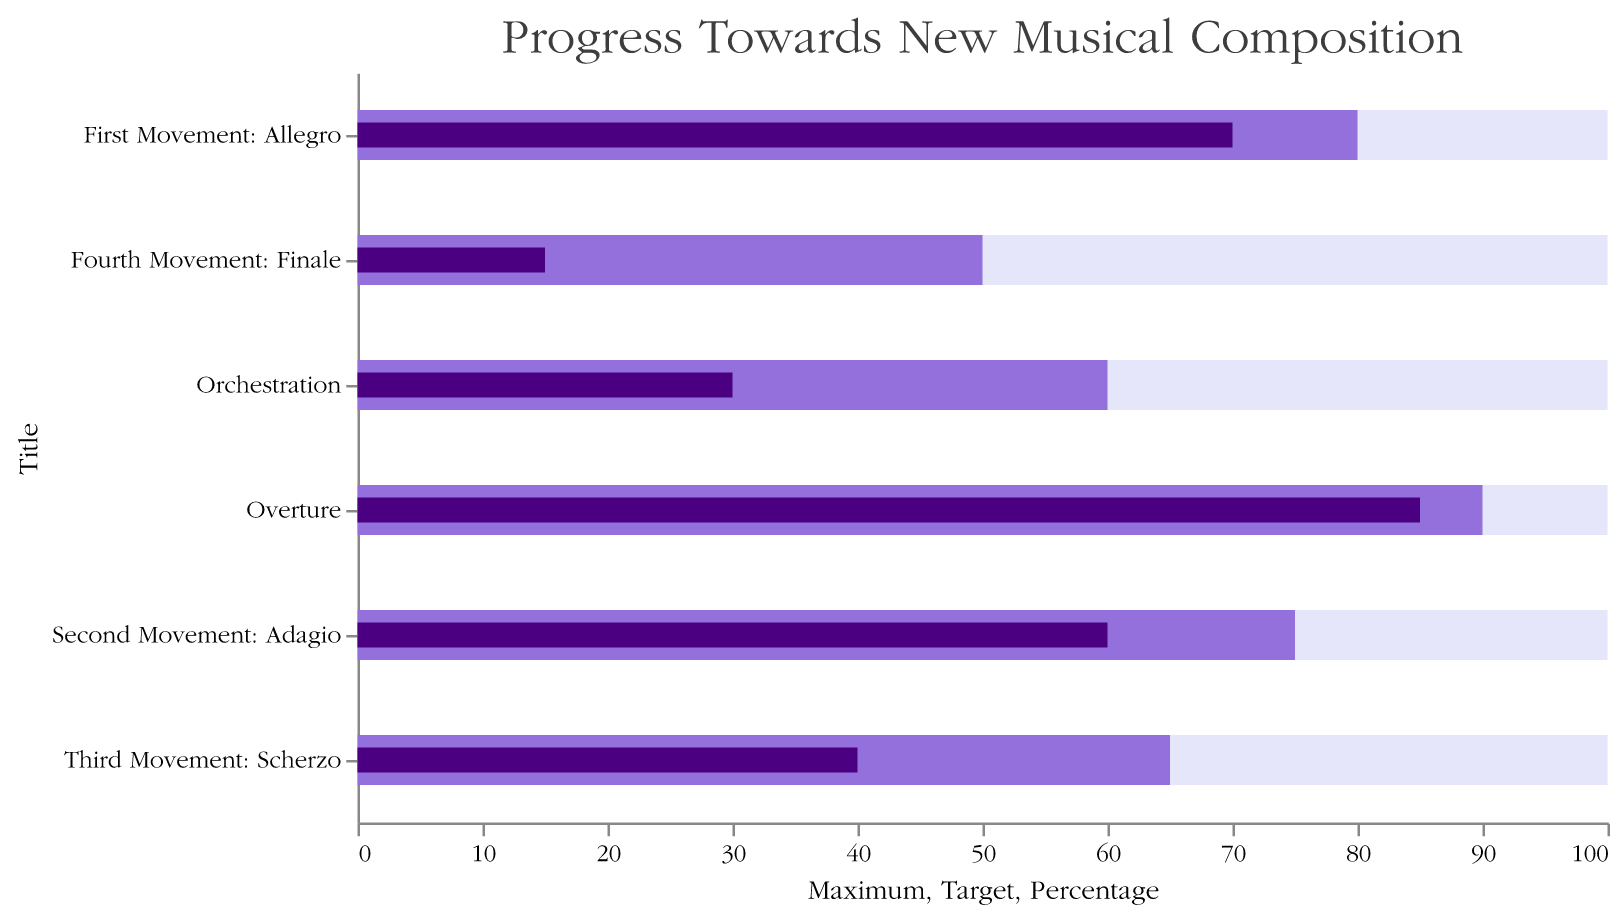What is the title of the chart? The title is at the top of the chart and is clearly labeled.
Answer: Progress Towards New Musical Composition Which movement has the highest percentage completion? The chart shows completion percentages for different movements. The Overture has the highest completion percentage at 85%.
Answer: Overture What is the target completion percentage for the Third Movement? The chart includes a target percentage for each movement. The target for the Third Movement: Scherzo is shown as 65%.
Answer: 65% What is the difference between the target and actual completion for the Second Movement? The target for the Second Movement: Adagio is 75%, and the actual completion is 60%. Subtracting the actual completion from the target gives the difference: 75% - 60% = 15%.
Answer: 15% Compare the completion percentages of the Orchestration and the Fourth Movement. Which one is higher? The completion percentages are visible for both categories: Orchestration is 30% and Fourth Movement: Finale is 15%. 30% is higher than 15%.
Answer: Orchestration Which part needs the most work to reach its target? The chart compares the actual percentage completed to the target. The largest gap between actual and target is for the Fourth Movement: Finale (15% out of 50%), meaning it needs the most work.
Answer: Fourth Movement: Finale How much more percentage completion is needed for the Overture to reach 100%? The Overture is at 85%, and 100% is the maximum. The difference is 100% - 85% = 15%.
Answer: 15% What is the average target completion percentage across all parts listed? Adding the target values for each part (90 + 80 + 75 + 65 + 50 + 60) gives 420. Dividing by the number of parts (6) gives the average: 420 / 6 = 70%.
Answer: 70% Between the First and Second Movements, which outstripped the other in terms of percentage towards their target? The First Movement: Allegro has a target of 80% and is 70% completed, which is 87.5% of its target. The Second Movement: Adagio has a target of 75% and is 60% completed, which is 80% of its target. Thus, the First Movement has a higher percentage towards its target.
Answer: First Movement: Allegro 